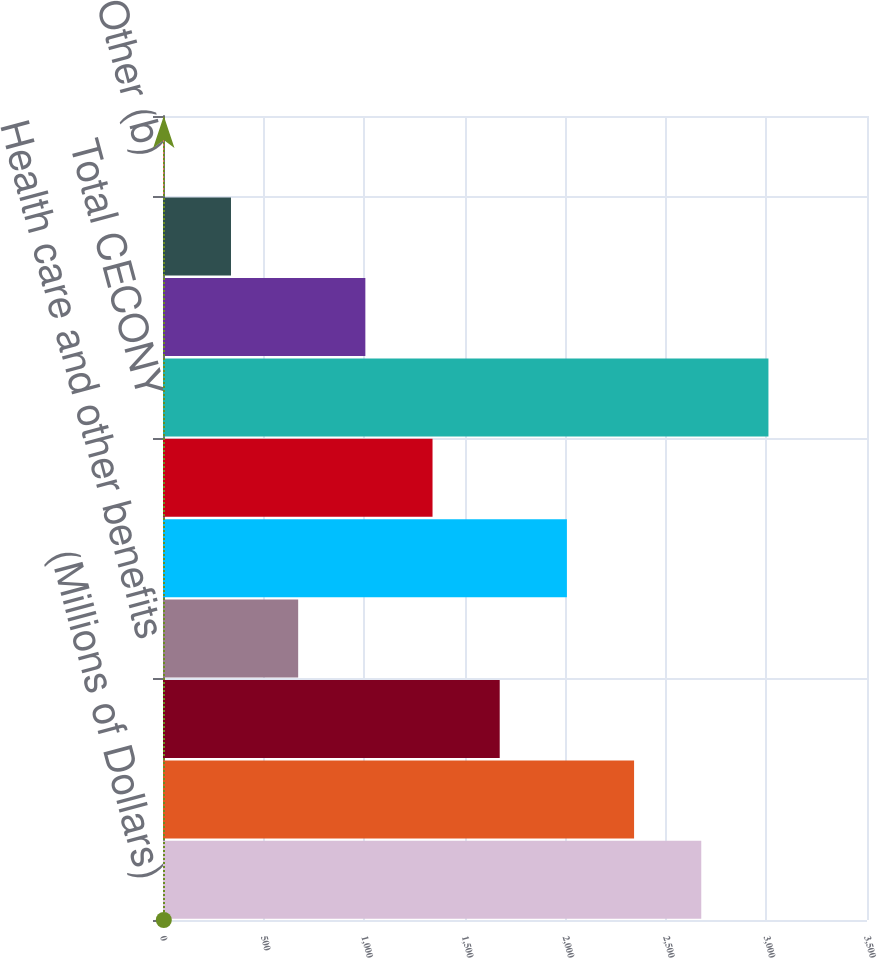Convert chart. <chart><loc_0><loc_0><loc_500><loc_500><bar_chart><fcel>(Millions of Dollars)<fcel>Operations<fcel>Pensions and other<fcel>Health care and other benefits<fcel>Regulatory fees and<fcel>Other<fcel>Total CECONY<fcel>O&R<fcel>Competitive energy businesses<fcel>Other (b)<nl><fcel>2676<fcel>2342<fcel>1674<fcel>672<fcel>2008<fcel>1340<fcel>3010<fcel>1006<fcel>338<fcel>4<nl></chart> 